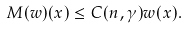Convert formula to latex. <formula><loc_0><loc_0><loc_500><loc_500>M ( w ) ( x ) \leq C ( n , \gamma ) w ( x ) .</formula> 